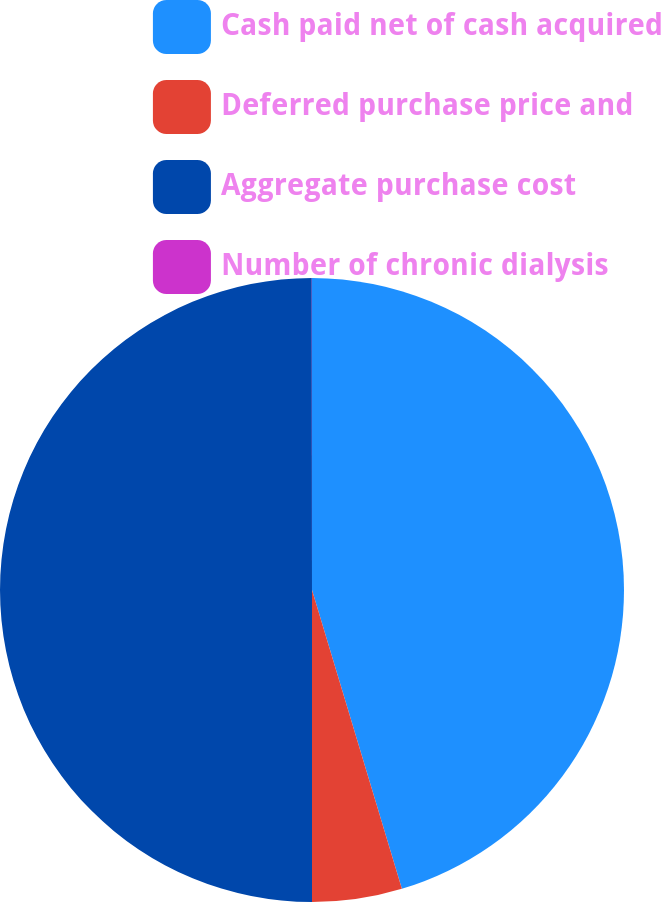Convert chart to OTSL. <chart><loc_0><loc_0><loc_500><loc_500><pie_chart><fcel>Cash paid net of cash acquired<fcel>Deferred purchase price and<fcel>Aggregate purchase cost<fcel>Number of chronic dialysis<nl><fcel>45.35%<fcel>4.65%<fcel>49.99%<fcel>0.01%<nl></chart> 